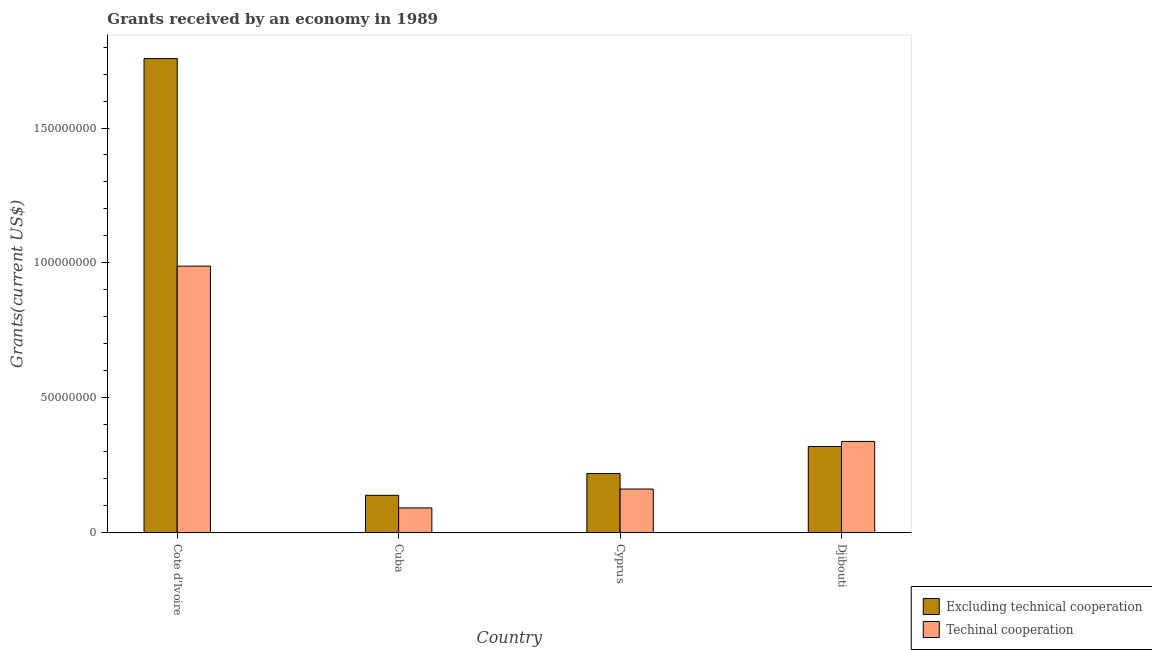Are the number of bars per tick equal to the number of legend labels?
Provide a succinct answer. Yes. Are the number of bars on each tick of the X-axis equal?
Keep it short and to the point. Yes. How many bars are there on the 2nd tick from the right?
Keep it short and to the point. 2. What is the label of the 1st group of bars from the left?
Your answer should be compact. Cote d'Ivoire. What is the amount of grants received(excluding technical cooperation) in Djibouti?
Your answer should be compact. 3.19e+07. Across all countries, what is the maximum amount of grants received(including technical cooperation)?
Keep it short and to the point. 9.88e+07. Across all countries, what is the minimum amount of grants received(excluding technical cooperation)?
Provide a succinct answer. 1.38e+07. In which country was the amount of grants received(excluding technical cooperation) maximum?
Ensure brevity in your answer.  Cote d'Ivoire. In which country was the amount of grants received(excluding technical cooperation) minimum?
Ensure brevity in your answer.  Cuba. What is the total amount of grants received(excluding technical cooperation) in the graph?
Provide a short and direct response. 2.43e+08. What is the difference between the amount of grants received(including technical cooperation) in Cote d'Ivoire and that in Cyprus?
Offer a very short reply. 8.26e+07. What is the difference between the amount of grants received(including technical cooperation) in Cuba and the amount of grants received(excluding technical cooperation) in Djibouti?
Your answer should be compact. -2.28e+07. What is the average amount of grants received(including technical cooperation) per country?
Provide a short and direct response. 3.95e+07. What is the difference between the amount of grants received(including technical cooperation) and amount of grants received(excluding technical cooperation) in Djibouti?
Your answer should be compact. 1.88e+06. In how many countries, is the amount of grants received(excluding technical cooperation) greater than 20000000 US$?
Keep it short and to the point. 3. What is the ratio of the amount of grants received(excluding technical cooperation) in Cuba to that in Djibouti?
Keep it short and to the point. 0.43. Is the amount of grants received(excluding technical cooperation) in Cyprus less than that in Djibouti?
Offer a very short reply. Yes. Is the difference between the amount of grants received(excluding technical cooperation) in Cuba and Cyprus greater than the difference between the amount of grants received(including technical cooperation) in Cuba and Cyprus?
Provide a succinct answer. No. What is the difference between the highest and the second highest amount of grants received(excluding technical cooperation)?
Your answer should be very brief. 1.44e+08. What is the difference between the highest and the lowest amount of grants received(including technical cooperation)?
Your response must be concise. 8.96e+07. In how many countries, is the amount of grants received(including technical cooperation) greater than the average amount of grants received(including technical cooperation) taken over all countries?
Your response must be concise. 1. Is the sum of the amount of grants received(including technical cooperation) in Cuba and Djibouti greater than the maximum amount of grants received(excluding technical cooperation) across all countries?
Your response must be concise. No. What does the 2nd bar from the left in Djibouti represents?
Your answer should be very brief. Techinal cooperation. What does the 2nd bar from the right in Cuba represents?
Your answer should be very brief. Excluding technical cooperation. Are all the bars in the graph horizontal?
Provide a short and direct response. No. What is the difference between two consecutive major ticks on the Y-axis?
Your response must be concise. 5.00e+07. What is the title of the graph?
Your answer should be very brief. Grants received by an economy in 1989. What is the label or title of the Y-axis?
Offer a very short reply. Grants(current US$). What is the Grants(current US$) in Excluding technical cooperation in Cote d'Ivoire?
Provide a succinct answer. 1.76e+08. What is the Grants(current US$) of Techinal cooperation in Cote d'Ivoire?
Ensure brevity in your answer.  9.88e+07. What is the Grants(current US$) in Excluding technical cooperation in Cuba?
Provide a short and direct response. 1.38e+07. What is the Grants(current US$) in Techinal cooperation in Cuba?
Your response must be concise. 9.15e+06. What is the Grants(current US$) in Excluding technical cooperation in Cyprus?
Provide a short and direct response. 2.19e+07. What is the Grants(current US$) of Techinal cooperation in Cyprus?
Your answer should be compact. 1.62e+07. What is the Grants(current US$) of Excluding technical cooperation in Djibouti?
Your response must be concise. 3.19e+07. What is the Grants(current US$) in Techinal cooperation in Djibouti?
Your response must be concise. 3.38e+07. Across all countries, what is the maximum Grants(current US$) of Excluding technical cooperation?
Make the answer very short. 1.76e+08. Across all countries, what is the maximum Grants(current US$) of Techinal cooperation?
Keep it short and to the point. 9.88e+07. Across all countries, what is the minimum Grants(current US$) in Excluding technical cooperation?
Keep it short and to the point. 1.38e+07. Across all countries, what is the minimum Grants(current US$) in Techinal cooperation?
Provide a short and direct response. 9.15e+06. What is the total Grants(current US$) in Excluding technical cooperation in the graph?
Give a very brief answer. 2.43e+08. What is the total Grants(current US$) of Techinal cooperation in the graph?
Your response must be concise. 1.58e+08. What is the difference between the Grants(current US$) of Excluding technical cooperation in Cote d'Ivoire and that in Cuba?
Your response must be concise. 1.62e+08. What is the difference between the Grants(current US$) in Techinal cooperation in Cote d'Ivoire and that in Cuba?
Ensure brevity in your answer.  8.96e+07. What is the difference between the Grants(current US$) in Excluding technical cooperation in Cote d'Ivoire and that in Cyprus?
Your answer should be very brief. 1.54e+08. What is the difference between the Grants(current US$) in Techinal cooperation in Cote d'Ivoire and that in Cyprus?
Your answer should be compact. 8.26e+07. What is the difference between the Grants(current US$) in Excluding technical cooperation in Cote d'Ivoire and that in Djibouti?
Your answer should be compact. 1.44e+08. What is the difference between the Grants(current US$) of Techinal cooperation in Cote d'Ivoire and that in Djibouti?
Ensure brevity in your answer.  6.50e+07. What is the difference between the Grants(current US$) of Excluding technical cooperation in Cuba and that in Cyprus?
Provide a short and direct response. -8.09e+06. What is the difference between the Grants(current US$) of Techinal cooperation in Cuba and that in Cyprus?
Offer a terse response. -7.00e+06. What is the difference between the Grants(current US$) in Excluding technical cooperation in Cuba and that in Djibouti?
Your response must be concise. -1.81e+07. What is the difference between the Grants(current US$) of Techinal cooperation in Cuba and that in Djibouti?
Keep it short and to the point. -2.46e+07. What is the difference between the Grants(current US$) of Excluding technical cooperation in Cyprus and that in Djibouti?
Provide a succinct answer. -1.00e+07. What is the difference between the Grants(current US$) in Techinal cooperation in Cyprus and that in Djibouti?
Offer a terse response. -1.76e+07. What is the difference between the Grants(current US$) in Excluding technical cooperation in Cote d'Ivoire and the Grants(current US$) in Techinal cooperation in Cuba?
Your answer should be compact. 1.67e+08. What is the difference between the Grants(current US$) in Excluding technical cooperation in Cote d'Ivoire and the Grants(current US$) in Techinal cooperation in Cyprus?
Your answer should be very brief. 1.60e+08. What is the difference between the Grants(current US$) in Excluding technical cooperation in Cote d'Ivoire and the Grants(current US$) in Techinal cooperation in Djibouti?
Offer a terse response. 1.42e+08. What is the difference between the Grants(current US$) of Excluding technical cooperation in Cuba and the Grants(current US$) of Techinal cooperation in Cyprus?
Offer a very short reply. -2.34e+06. What is the difference between the Grants(current US$) in Excluding technical cooperation in Cuba and the Grants(current US$) in Techinal cooperation in Djibouti?
Your response must be concise. -2.00e+07. What is the difference between the Grants(current US$) in Excluding technical cooperation in Cyprus and the Grants(current US$) in Techinal cooperation in Djibouti?
Provide a short and direct response. -1.19e+07. What is the average Grants(current US$) of Excluding technical cooperation per country?
Provide a short and direct response. 6.08e+07. What is the average Grants(current US$) of Techinal cooperation per country?
Your answer should be very brief. 3.95e+07. What is the difference between the Grants(current US$) of Excluding technical cooperation and Grants(current US$) of Techinal cooperation in Cote d'Ivoire?
Provide a short and direct response. 7.70e+07. What is the difference between the Grants(current US$) in Excluding technical cooperation and Grants(current US$) in Techinal cooperation in Cuba?
Ensure brevity in your answer.  4.66e+06. What is the difference between the Grants(current US$) in Excluding technical cooperation and Grants(current US$) in Techinal cooperation in Cyprus?
Offer a very short reply. 5.75e+06. What is the difference between the Grants(current US$) in Excluding technical cooperation and Grants(current US$) in Techinal cooperation in Djibouti?
Offer a very short reply. -1.88e+06. What is the ratio of the Grants(current US$) of Excluding technical cooperation in Cote d'Ivoire to that in Cuba?
Offer a very short reply. 12.73. What is the ratio of the Grants(current US$) in Techinal cooperation in Cote d'Ivoire to that in Cuba?
Provide a short and direct response. 10.8. What is the ratio of the Grants(current US$) in Excluding technical cooperation in Cote d'Ivoire to that in Cyprus?
Offer a very short reply. 8.03. What is the ratio of the Grants(current US$) of Techinal cooperation in Cote d'Ivoire to that in Cyprus?
Offer a very short reply. 6.12. What is the ratio of the Grants(current US$) of Excluding technical cooperation in Cote d'Ivoire to that in Djibouti?
Your answer should be very brief. 5.51. What is the ratio of the Grants(current US$) in Techinal cooperation in Cote d'Ivoire to that in Djibouti?
Keep it short and to the point. 2.92. What is the ratio of the Grants(current US$) of Excluding technical cooperation in Cuba to that in Cyprus?
Provide a short and direct response. 0.63. What is the ratio of the Grants(current US$) of Techinal cooperation in Cuba to that in Cyprus?
Give a very brief answer. 0.57. What is the ratio of the Grants(current US$) in Excluding technical cooperation in Cuba to that in Djibouti?
Make the answer very short. 0.43. What is the ratio of the Grants(current US$) of Techinal cooperation in Cuba to that in Djibouti?
Your answer should be compact. 0.27. What is the ratio of the Grants(current US$) in Excluding technical cooperation in Cyprus to that in Djibouti?
Provide a short and direct response. 0.69. What is the ratio of the Grants(current US$) of Techinal cooperation in Cyprus to that in Djibouti?
Give a very brief answer. 0.48. What is the difference between the highest and the second highest Grants(current US$) of Excluding technical cooperation?
Make the answer very short. 1.44e+08. What is the difference between the highest and the second highest Grants(current US$) in Techinal cooperation?
Provide a succinct answer. 6.50e+07. What is the difference between the highest and the lowest Grants(current US$) of Excluding technical cooperation?
Your response must be concise. 1.62e+08. What is the difference between the highest and the lowest Grants(current US$) of Techinal cooperation?
Your answer should be very brief. 8.96e+07. 